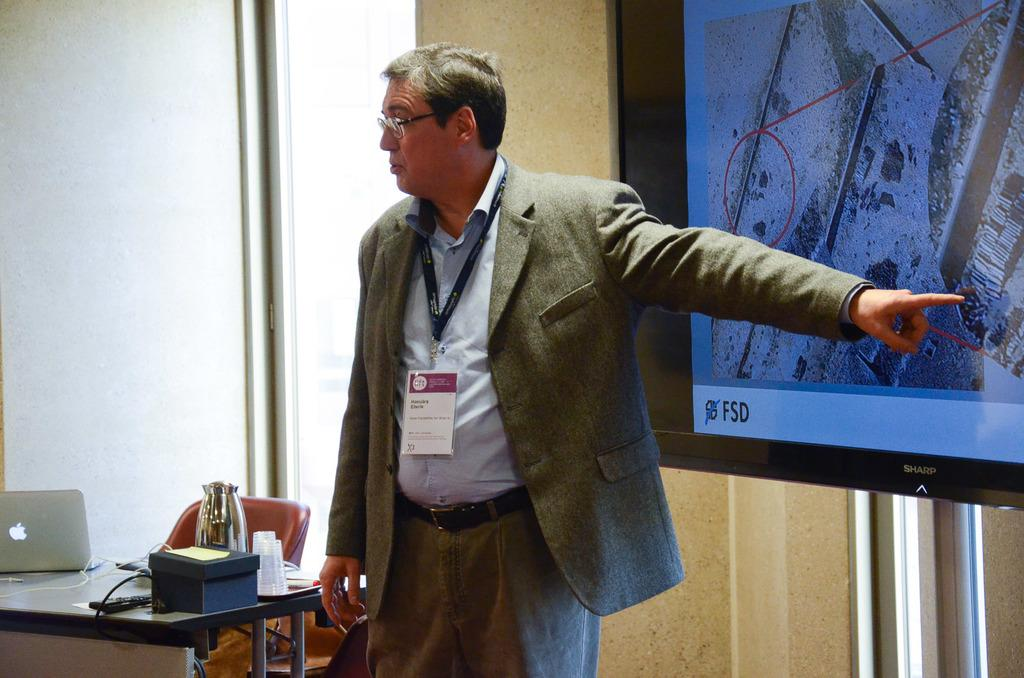Who or what is present in the image? There is a person in the image. What is the person using or interacting with in the image? There is a table in the image, and the person might be using or interacting with it. What objects are on the table in the image? There is a laptop and a kettle on the table in the image. What type of paint is being used by the person in the image? There is no paint or painting activity present in the image. 